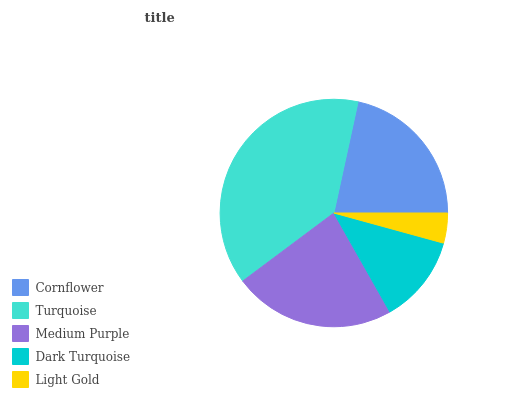Is Light Gold the minimum?
Answer yes or no. Yes. Is Turquoise the maximum?
Answer yes or no. Yes. Is Medium Purple the minimum?
Answer yes or no. No. Is Medium Purple the maximum?
Answer yes or no. No. Is Turquoise greater than Medium Purple?
Answer yes or no. Yes. Is Medium Purple less than Turquoise?
Answer yes or no. Yes. Is Medium Purple greater than Turquoise?
Answer yes or no. No. Is Turquoise less than Medium Purple?
Answer yes or no. No. Is Cornflower the high median?
Answer yes or no. Yes. Is Cornflower the low median?
Answer yes or no. Yes. Is Dark Turquoise the high median?
Answer yes or no. No. Is Light Gold the low median?
Answer yes or no. No. 